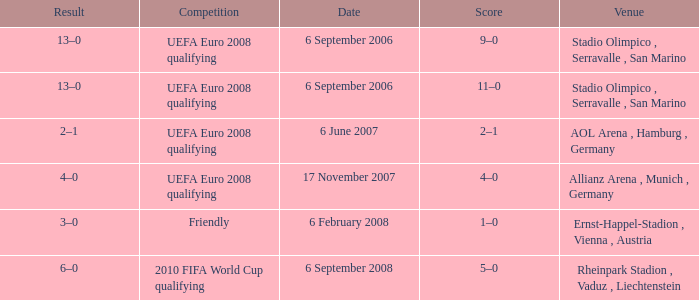On what Date did the friendly Competition take place? 6 February 2008. 